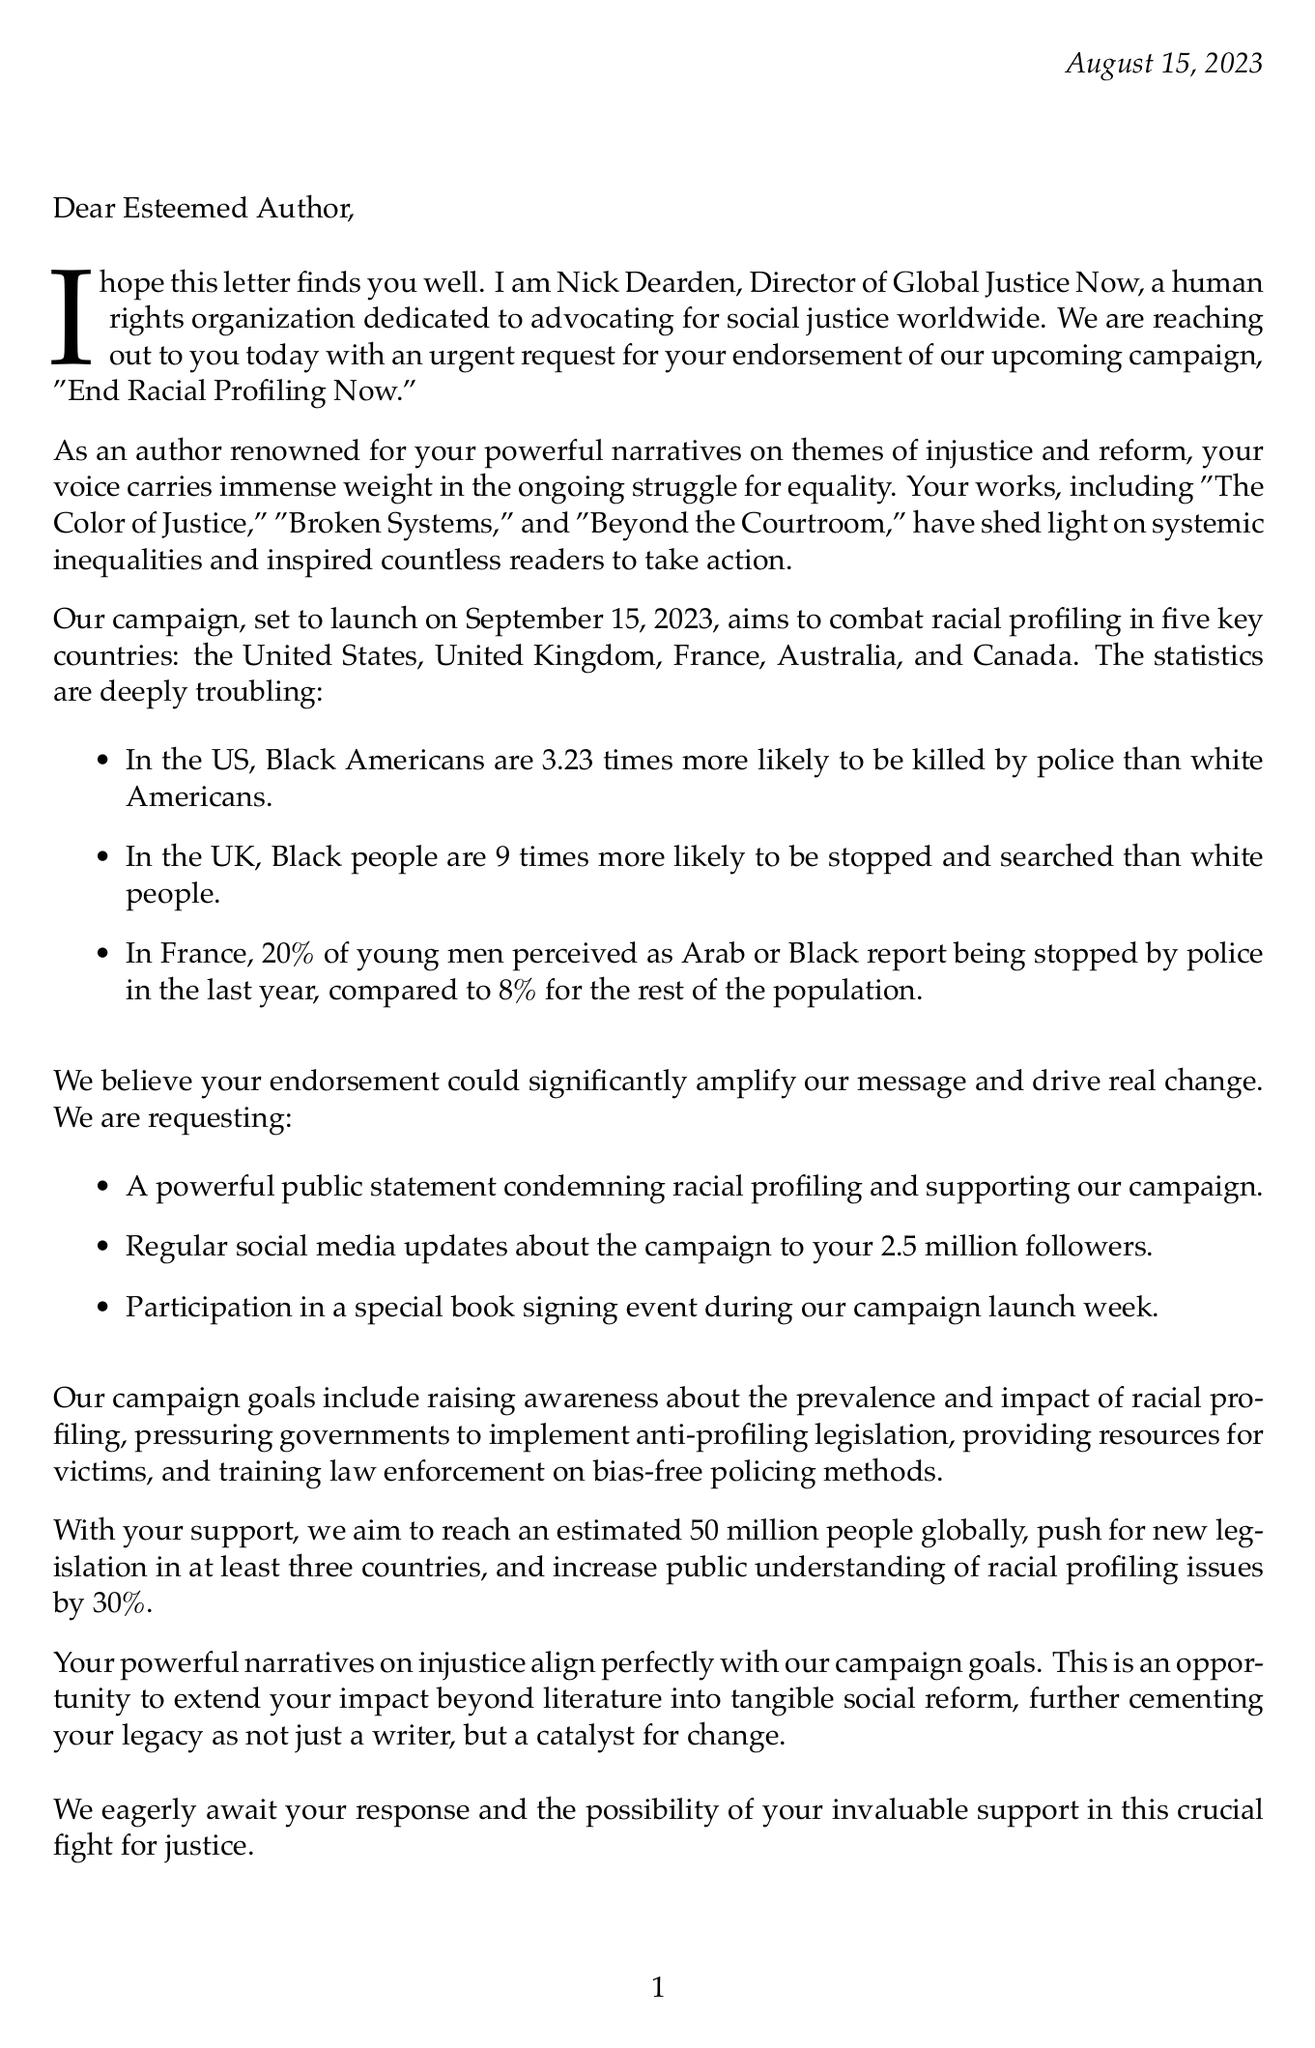What is the name of the organization? The organization mentioned in the document is named Global Justice Now.
Answer: Global Justice Now Who is the director of the organization? The document states that the director of Global Justice Now is Nick Dearden.
Answer: Nick Dearden When is the campaign launch date? According to the document, the campaign "End Racial Profiling Now" is set to launch on September 15, 2023.
Answer: September 15, 2023 How many key countries are targeted in the campaign? The document indicates that there are five key countries targeted for the campaign.
Answer: Five What is the primary goal of the campaign? The campaign aims to raise awareness about the prevalence and impact of racial profiling.
Answer: Raise awareness about racial profiling What percentage of young men perceived as Arab or Black in France have been stopped by police? The document states that 20% of young men perceived as Arab or Black report being stopped by police in the last year.
Answer: 20% What type of public statement is requested from the author? The organization is requesting a powerful public statement condemning racial profiling.
Answer: A powerful public statement What is the estimated reach of the campaign globally? The document mentions that the campaign aims to reach an estimated 50 million people globally.
Answer: 50 million people How many awards has the author won? The document lists two notable awards that the author has won.
Answer: Two 